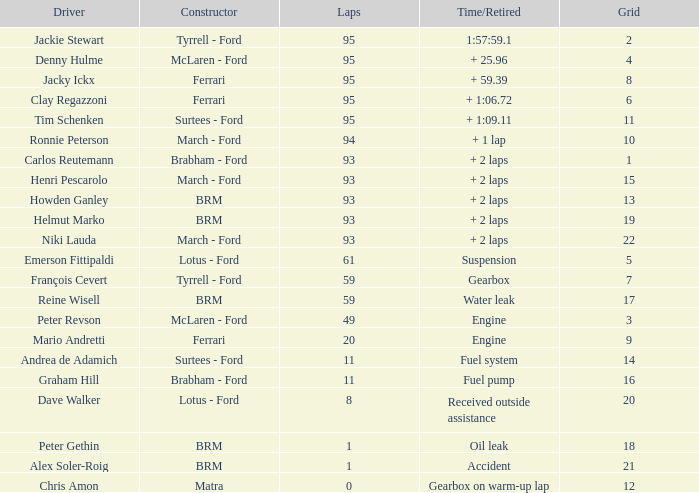Which grid has under 11 laps, and a time/retired due to accident? 21.0. 